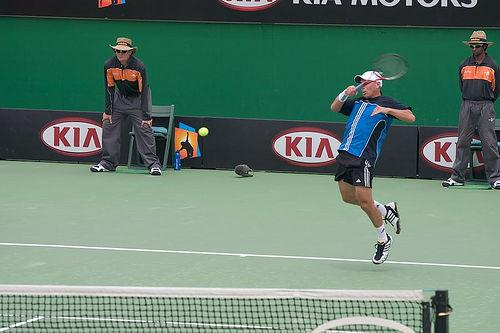What did the man in the blue shirt just do? Please explain your reasoning. returned ball. He can be seen in the air, meaning he just jumped to return the ball to the other side of the net. 